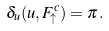Convert formula to latex. <formula><loc_0><loc_0><loc_500><loc_500>\delta _ { u } ( u , F _ { \uparrow } ^ { c } ) = \pi \, .</formula> 